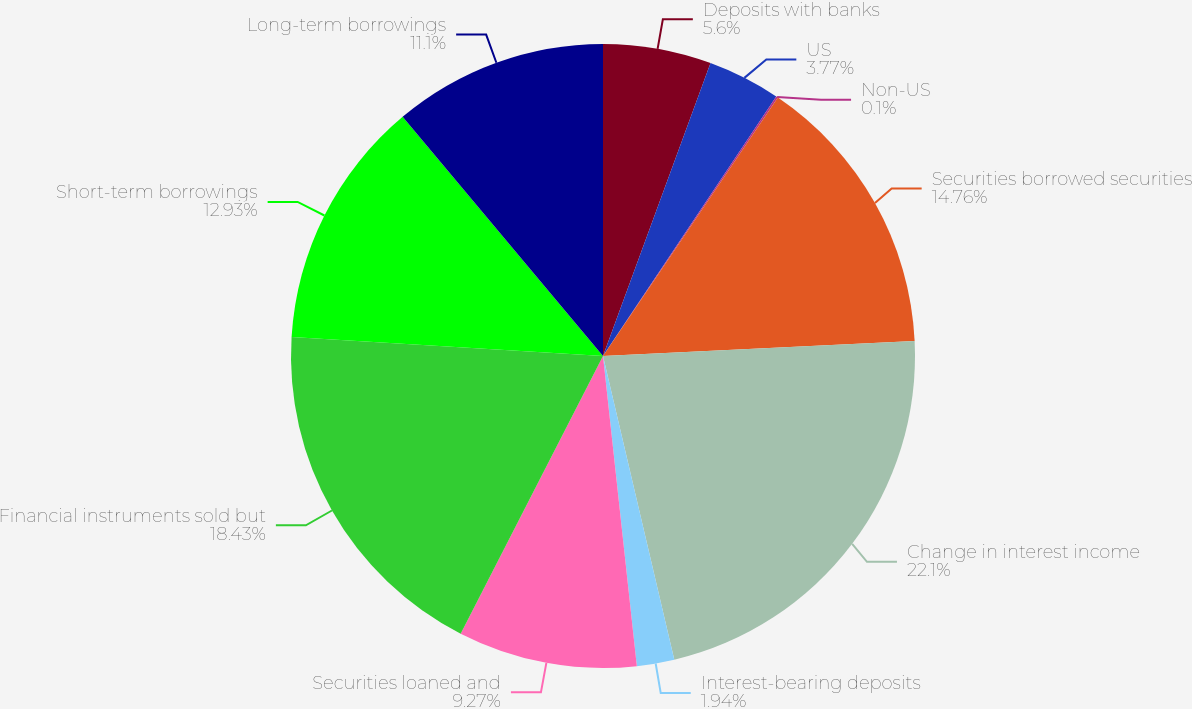Convert chart to OTSL. <chart><loc_0><loc_0><loc_500><loc_500><pie_chart><fcel>Deposits with banks<fcel>US<fcel>Non-US<fcel>Securities borrowed securities<fcel>Change in interest income<fcel>Interest-bearing deposits<fcel>Securities loaned and<fcel>Financial instruments sold but<fcel>Short-term borrowings<fcel>Long-term borrowings<nl><fcel>5.6%<fcel>3.77%<fcel>0.1%<fcel>14.76%<fcel>22.1%<fcel>1.94%<fcel>9.27%<fcel>18.43%<fcel>12.93%<fcel>11.1%<nl></chart> 